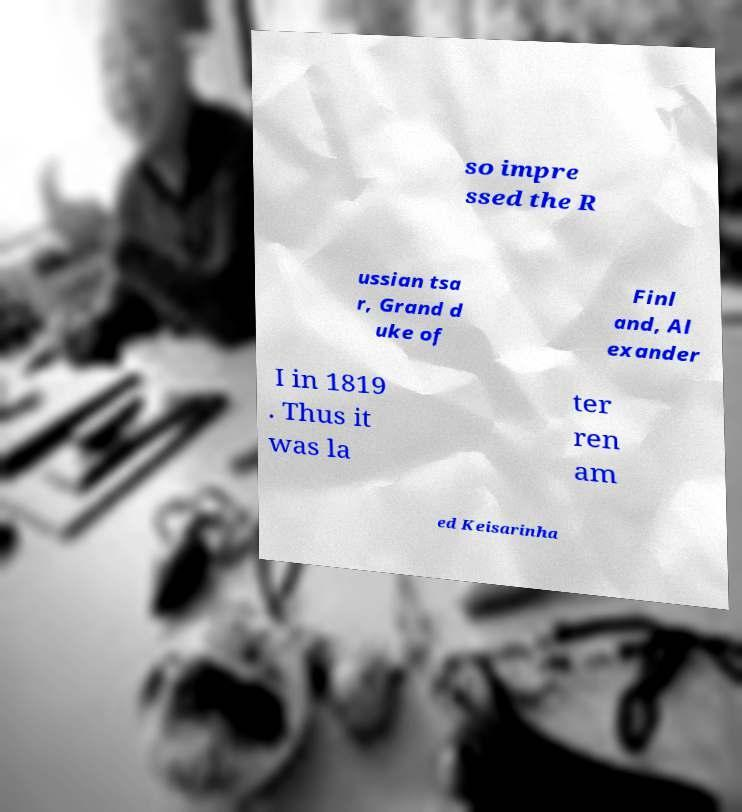Can you read and provide the text displayed in the image?This photo seems to have some interesting text. Can you extract and type it out for me? so impre ssed the R ussian tsa r, Grand d uke of Finl and, Al exander I in 1819 . Thus it was la ter ren am ed Keisarinha 